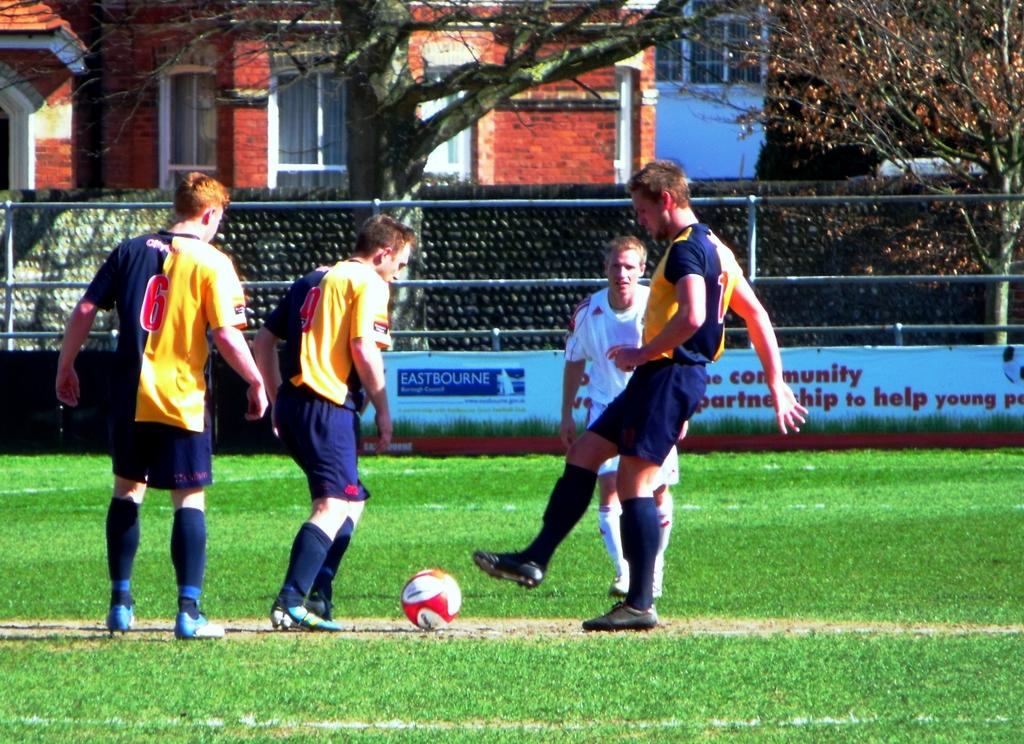<image>
Render a clear and concise summary of the photo. Three players from the same team, one with the number 6 on his shirt. 